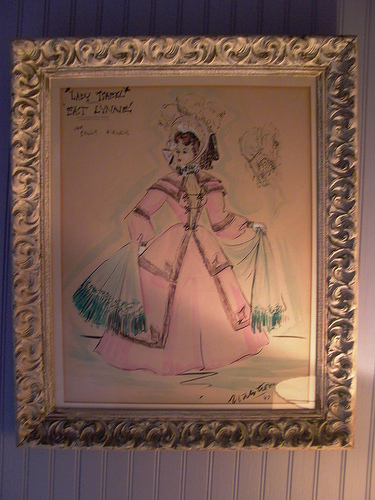<image>
Is the shawl under the girl? Yes. The shawl is positioned underneath the girl, with the girl above it in the vertical space. 